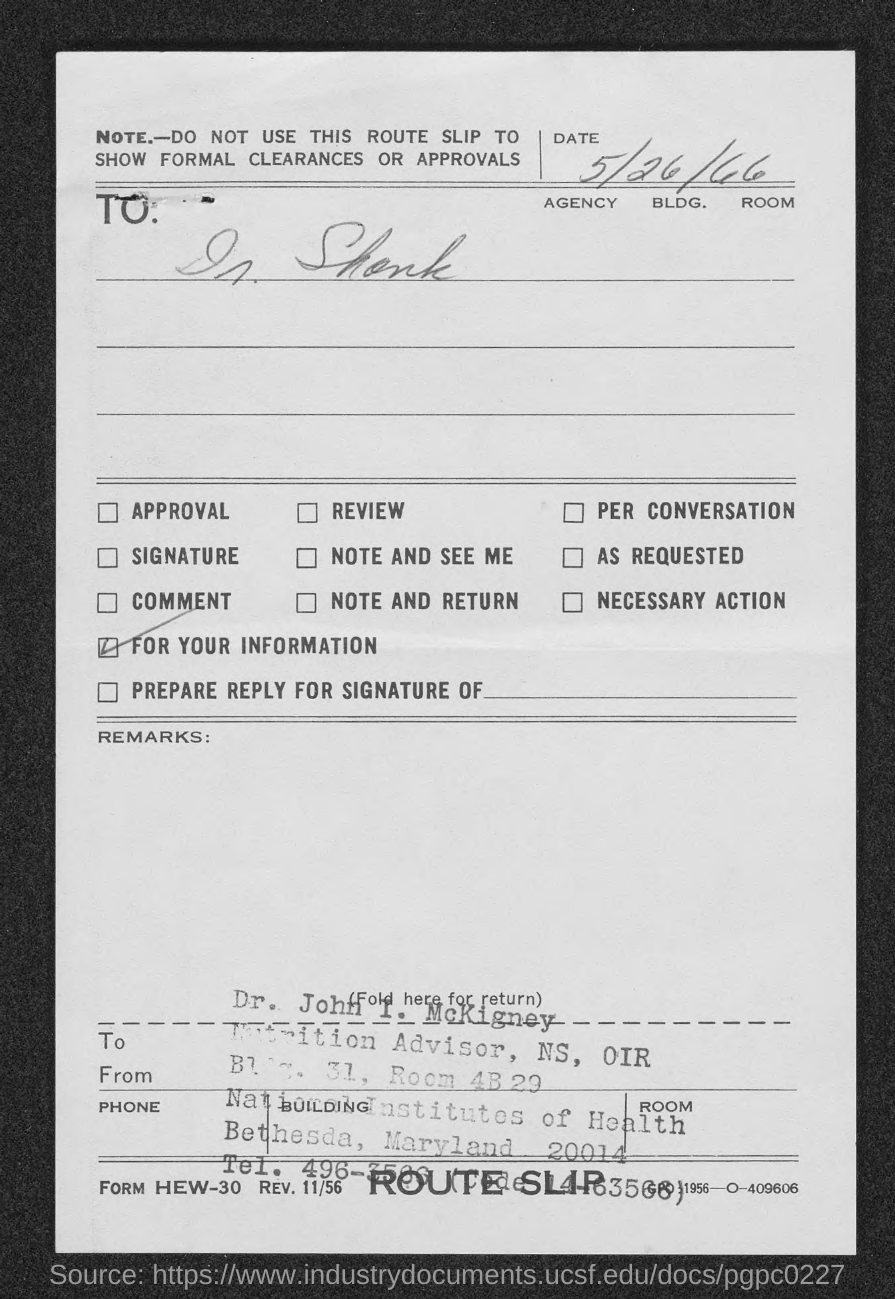What is the date mentioned in the slip?
Your answer should be very brief. 5/26/66. What is name written with stamp?
Your answer should be very brief. Dr. John I. McKigney. Where "National Institutes of Health" is located?
Ensure brevity in your answer.  Bethesda, Maryland. 